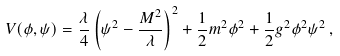<formula> <loc_0><loc_0><loc_500><loc_500>V ( \phi , \psi ) = \frac { \lambda } { 4 } \left ( \psi ^ { 2 } - \frac { M ^ { 2 } } { \lambda } \right ) ^ { 2 } + \frac { 1 } { 2 } m ^ { 2 } \phi ^ { 2 } + \frac { 1 } { 2 } g ^ { 2 } \phi ^ { 2 } \psi ^ { 2 } \, ,</formula> 